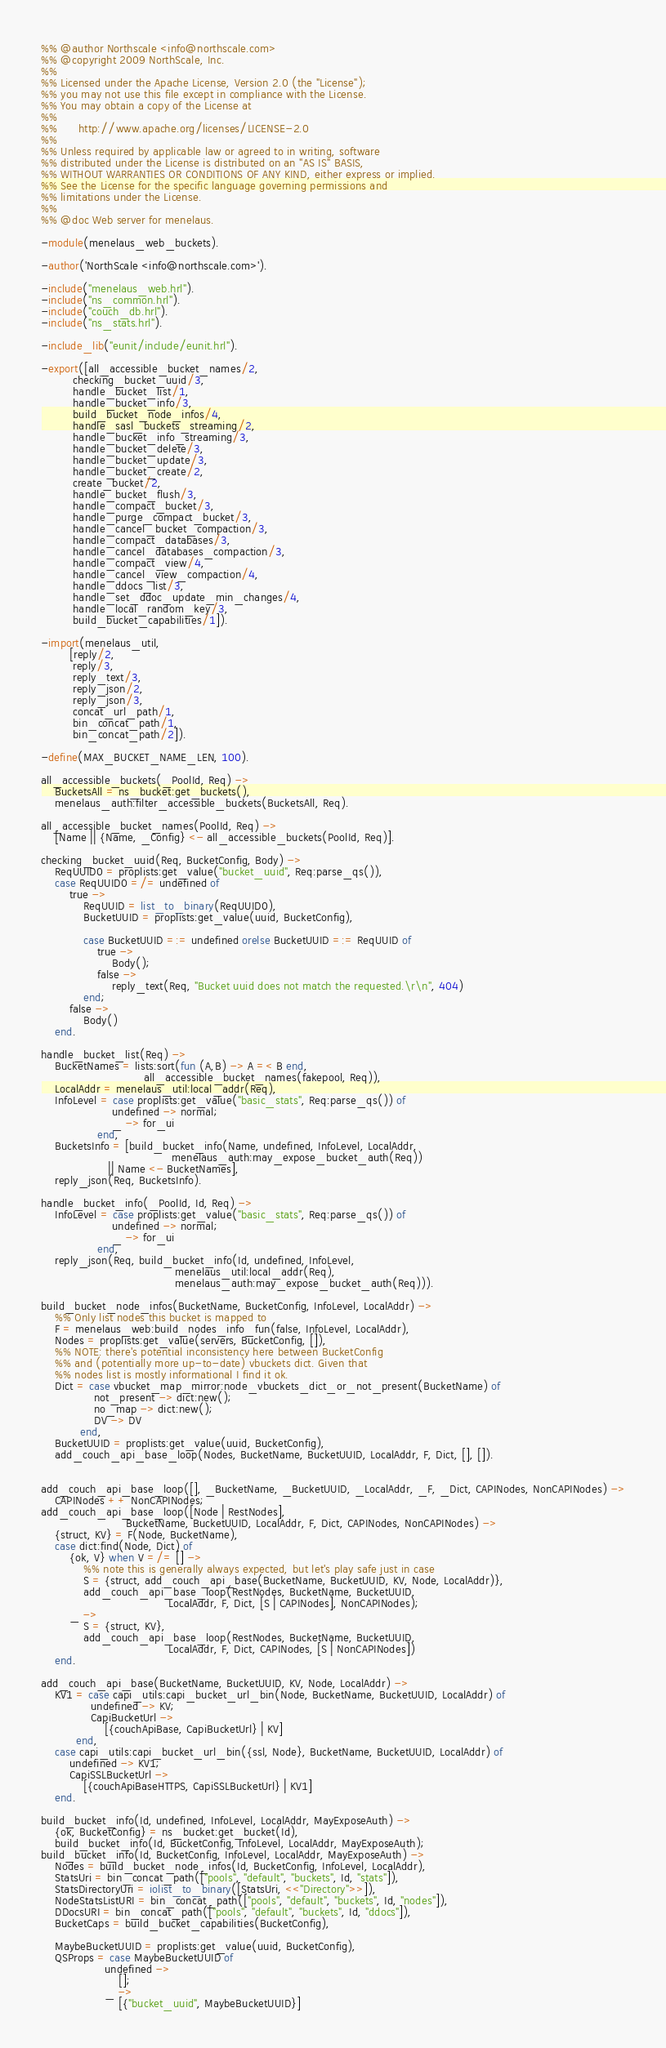Convert code to text. <code><loc_0><loc_0><loc_500><loc_500><_Erlang_>%% @author Northscale <info@northscale.com>
%% @copyright 2009 NorthScale, Inc.
%%
%% Licensed under the Apache License, Version 2.0 (the "License");
%% you may not use this file except in compliance with the License.
%% You may obtain a copy of the License at
%%
%%      http://www.apache.org/licenses/LICENSE-2.0
%%
%% Unless required by applicable law or agreed to in writing, software
%% distributed under the License is distributed on an "AS IS" BASIS,
%% WITHOUT WARRANTIES OR CONDITIONS OF ANY KIND, either express or implied.
%% See the License for the specific language governing permissions and
%% limitations under the License.
%%
%% @doc Web server for menelaus.

-module(menelaus_web_buckets).

-author('NorthScale <info@northscale.com>').

-include("menelaus_web.hrl").
-include("ns_common.hrl").
-include("couch_db.hrl").
-include("ns_stats.hrl").

-include_lib("eunit/include/eunit.hrl").

-export([all_accessible_bucket_names/2,
         checking_bucket_uuid/3,
         handle_bucket_list/1,
         handle_bucket_info/3,
         build_bucket_node_infos/4,
         handle_sasl_buckets_streaming/2,
         handle_bucket_info_streaming/3,
         handle_bucket_delete/3,
         handle_bucket_update/3,
         handle_bucket_create/2,
         create_bucket/2,
         handle_bucket_flush/3,
         handle_compact_bucket/3,
         handle_purge_compact_bucket/3,
         handle_cancel_bucket_compaction/3,
         handle_compact_databases/3,
         handle_cancel_databases_compaction/3,
         handle_compact_view/4,
         handle_cancel_view_compaction/4,
         handle_ddocs_list/3,
         handle_set_ddoc_update_min_changes/4,
         handle_local_random_key/3,
         build_bucket_capabilities/1]).

-import(menelaus_util,
        [reply/2,
         reply/3,
         reply_text/3,
         reply_json/2,
         reply_json/3,
         concat_url_path/1,
         bin_concat_path/1,
         bin_concat_path/2]).

-define(MAX_BUCKET_NAME_LEN, 100).

all_accessible_buckets(_PoolId, Req) ->
    BucketsAll = ns_bucket:get_buckets(),
    menelaus_auth:filter_accessible_buckets(BucketsAll, Req).

all_accessible_bucket_names(PoolId, Req) ->
    [Name || {Name, _Config} <- all_accessible_buckets(PoolId, Req)].

checking_bucket_uuid(Req, BucketConfig, Body) ->
    ReqUUID0 = proplists:get_value("bucket_uuid", Req:parse_qs()),
    case ReqUUID0 =/= undefined of
        true ->
            ReqUUID = list_to_binary(ReqUUID0),
            BucketUUID = proplists:get_value(uuid, BucketConfig),

            case BucketUUID =:= undefined orelse BucketUUID =:= ReqUUID of
                true ->
                    Body();
                false ->
                    reply_text(Req, "Bucket uuid does not match the requested.\r\n", 404)
            end;
        false ->
            Body()
    end.

handle_bucket_list(Req) ->
    BucketNames = lists:sort(fun (A,B) -> A =< B end,
                             all_accessible_bucket_names(fakepool, Req)),
    LocalAddr = menelaus_util:local_addr(Req),
    InfoLevel = case proplists:get_value("basic_stats", Req:parse_qs()) of
                    undefined -> normal;
                    _ -> for_ui
                end,
    BucketsInfo = [build_bucket_info(Name, undefined, InfoLevel, LocalAddr,
                                     menelaus_auth:may_expose_bucket_auth(Req))
                   || Name <- BucketNames],
    reply_json(Req, BucketsInfo).

handle_bucket_info(_PoolId, Id, Req) ->
    InfoLevel = case proplists:get_value("basic_stats", Req:parse_qs()) of
                    undefined -> normal;
                    _ -> for_ui
                end,
    reply_json(Req, build_bucket_info(Id, undefined, InfoLevel,
                                      menelaus_util:local_addr(Req),
                                      menelaus_auth:may_expose_bucket_auth(Req))).

build_bucket_node_infos(BucketName, BucketConfig, InfoLevel, LocalAddr) ->
    %% Only list nodes this bucket is mapped to
    F = menelaus_web:build_nodes_info_fun(false, InfoLevel, LocalAddr),
    Nodes = proplists:get_value(servers, BucketConfig, []),
    %% NOTE: there's potential inconsistency here between BucketConfig
    %% and (potentially more up-to-date) vbuckets dict. Given that
    %% nodes list is mostly informational I find it ok.
    Dict = case vbucket_map_mirror:node_vbuckets_dict_or_not_present(BucketName) of
               not_present -> dict:new();
               no_map -> dict:new();
               DV -> DV
           end,
    BucketUUID = proplists:get_value(uuid, BucketConfig),
    add_couch_api_base_loop(Nodes, BucketName, BucketUUID, LocalAddr, F, Dict, [], []).


add_couch_api_base_loop([], _BucketName, _BucketUUID, _LocalAddr, _F, _Dict, CAPINodes, NonCAPINodes) ->
    CAPINodes ++ NonCAPINodes;
add_couch_api_base_loop([Node | RestNodes],
                        BucketName, BucketUUID, LocalAddr, F, Dict, CAPINodes, NonCAPINodes) ->
    {struct, KV} = F(Node, BucketName),
    case dict:find(Node, Dict) of
        {ok, V} when V =/= [] ->
            %% note this is generally always expected, but let's play safe just in case
            S = {struct, add_couch_api_base(BucketName, BucketUUID, KV, Node, LocalAddr)},
            add_couch_api_base_loop(RestNodes, BucketName, BucketUUID,
                                    LocalAddr, F, Dict, [S | CAPINodes], NonCAPINodes);
        _ ->
            S = {struct, KV},
            add_couch_api_base_loop(RestNodes, BucketName, BucketUUID,
                                    LocalAddr, F, Dict, CAPINodes, [S | NonCAPINodes])
    end.

add_couch_api_base(BucketName, BucketUUID, KV, Node, LocalAddr) ->
    KV1 = case capi_utils:capi_bucket_url_bin(Node, BucketName, BucketUUID, LocalAddr) of
              undefined -> KV;
              CapiBucketUrl ->
                  [{couchApiBase, CapiBucketUrl} | KV]
          end,
    case capi_utils:capi_bucket_url_bin({ssl, Node}, BucketName, BucketUUID, LocalAddr) of
        undefined -> KV1;
        CapiSSLBucketUrl ->
            [{couchApiBaseHTTPS, CapiSSLBucketUrl} | KV1]
    end.

build_bucket_info(Id, undefined, InfoLevel, LocalAddr, MayExposeAuth) ->
    {ok, BucketConfig} = ns_bucket:get_bucket(Id),
    build_bucket_info(Id, BucketConfig, InfoLevel, LocalAddr, MayExposeAuth);
build_bucket_info(Id, BucketConfig, InfoLevel, LocalAddr, MayExposeAuth) ->
    Nodes = build_bucket_node_infos(Id, BucketConfig, InfoLevel, LocalAddr),
    StatsUri = bin_concat_path(["pools", "default", "buckets", Id, "stats"]),
    StatsDirectoryUri = iolist_to_binary([StatsUri, <<"Directory">>]),
    NodeStatsListURI = bin_concat_path(["pools", "default", "buckets", Id, "nodes"]),
    DDocsURI = bin_concat_path(["pools", "default", "buckets", Id, "ddocs"]),
    BucketCaps = build_bucket_capabilities(BucketConfig),

    MaybeBucketUUID = proplists:get_value(uuid, BucketConfig),
    QSProps = case MaybeBucketUUID of
                  undefined ->
                      [];
                  _ ->
                      [{"bucket_uuid", MaybeBucketUUID}]</code> 